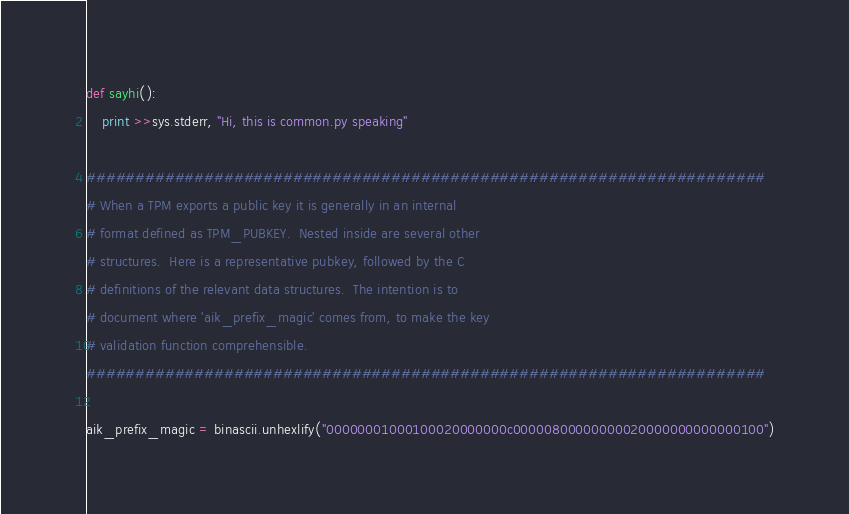Convert code to text. <code><loc_0><loc_0><loc_500><loc_500><_Python_>
def sayhi():
    print >>sys.stderr, "Hi, this is common.py speaking"

#####################################################################
# When a TPM exports a public key it is generally in an internal
# format defined as TPM_PUBKEY.  Nested inside are several other
# structures.  Here is a representative pubkey, followed by the C
# definitions of the relevant data structures.  The intention is to
# document where 'aik_prefix_magic' comes from, to make the key
# validation function comprehensible.
#####################################################################

aik_prefix_magic = binascii.unhexlify("00000001000100020000000c00000800000000020000000000000100")
</code> 